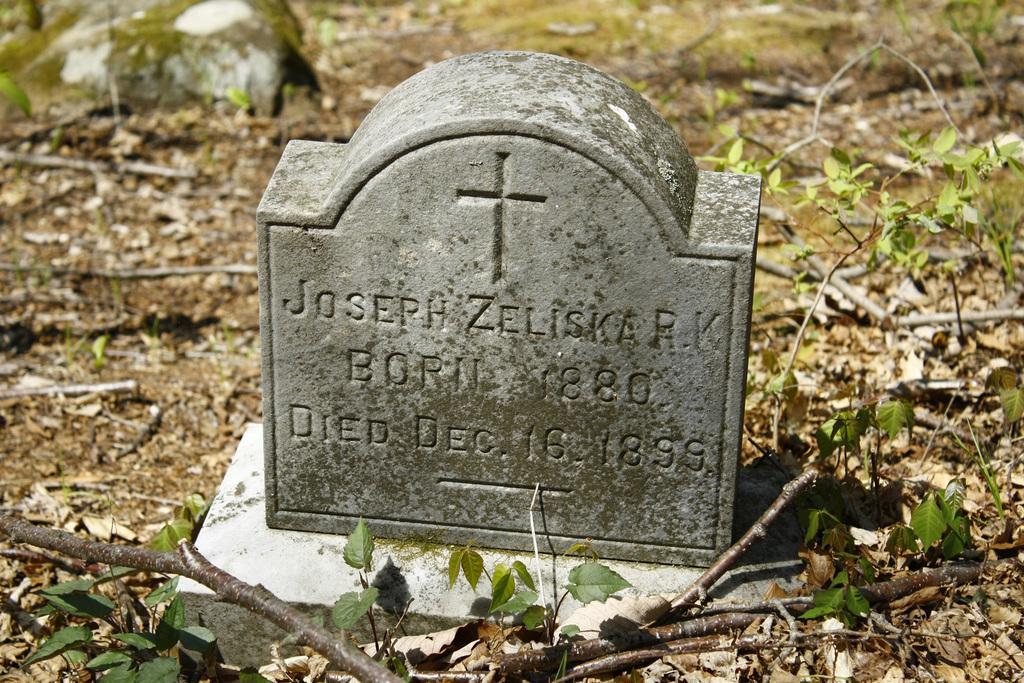Please provide a concise description of this image. In this image I can see a memorial stone and in the background there are leaves. 